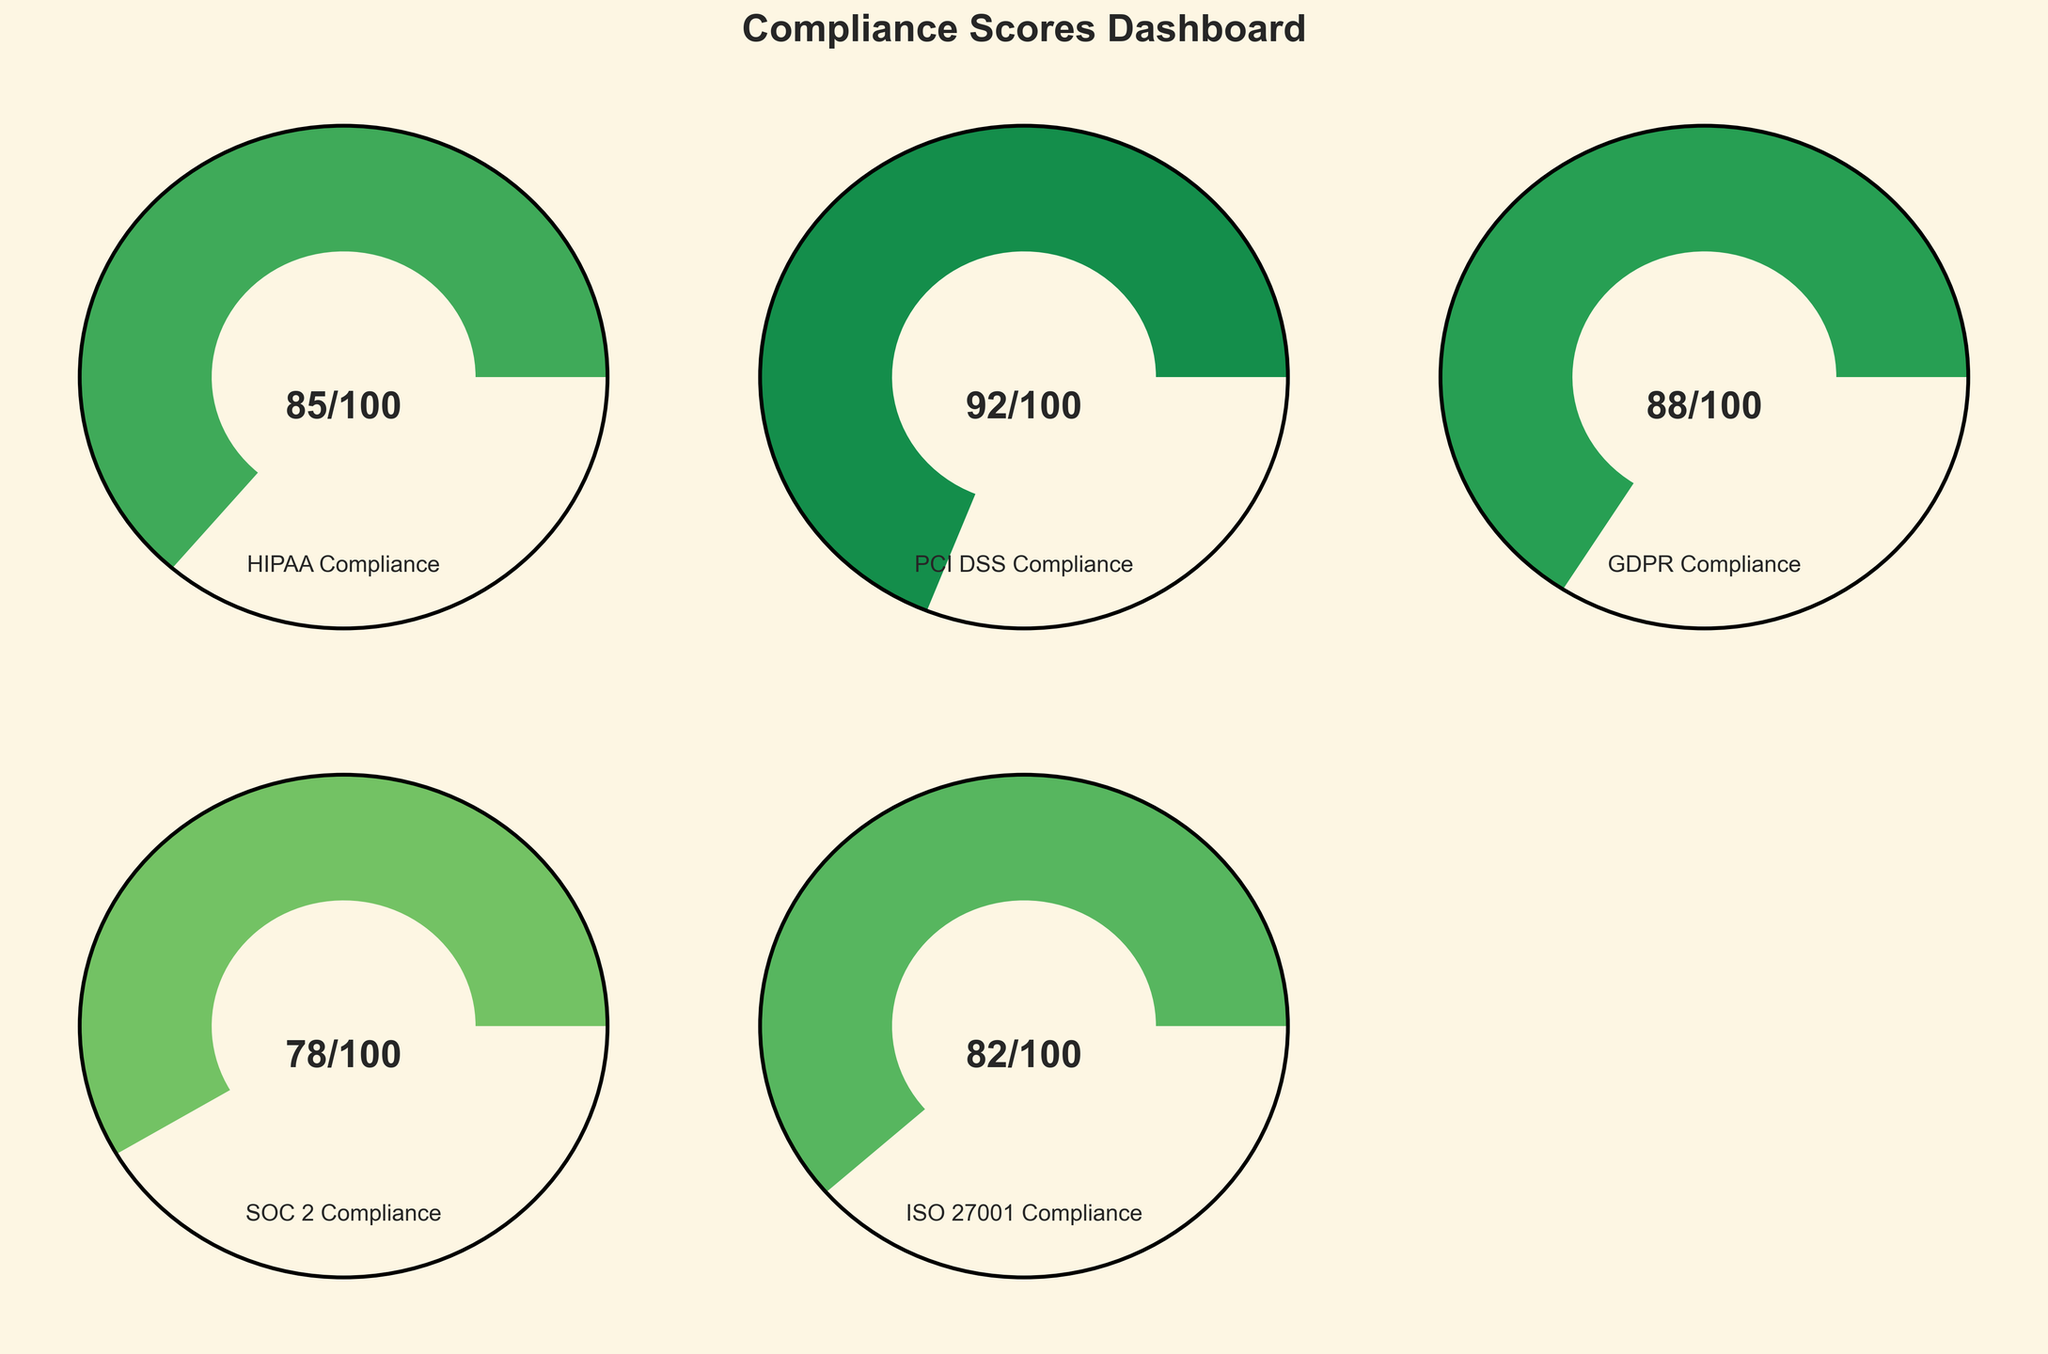What's the title of the figure? The title is prominently displayed at the top of the figure and reads 'Compliance Scores Dashboard'.
Answer: Compliance Scores Dashboard How many categories of compliance scores are shown in the figure? The figure displays one gauge chart for each category of compliance score. We count the number of distinct categories labeled in each gauge chart.
Answer: 5 Which compliance category has the highest score? By looking at the scores shown in each gauge chart, PCI DSS Compliance has the highest score of 92 out of 100.
Answer: PCI DSS Compliance What is the score for SOC 2 Compliance? The score for SOC 2 Compliance is specifically labeled on its corresponding gauge chart and reads 78 out of 100.
Answer: 78 What is the average compliance score across all categories? To calculate the average, sum all the scores (85 + 92 + 88 + 78 + 82) which is 425, then divide by the number of categories which is 5. The average score is 425/5 = 85.
Answer: 85 Which compliance category has the lowest score? By comparing the scores displayed on each gauge chart, SOC 2 Compliance has the lowest score of 78 out of 100.
Answer: SOC 2 Compliance Compare the scores of HIPAA Compliance and GDPR Compliance. Which one is higher and by how much? HIPAA Compliance has a score of 85, while GDPR Compliance has a score of 88. By subtracting the scores, 88 - 85, we see that GDPR Compliance is 3 points higher than HIPAA Compliance.
Answer: GDPR Compliance by 3 points What are the gauge colors representing the scores based on? The gauge colors are determined by the compliance score, with higher scores represented by greener colors and lower scores by redder colors, based on a colormap spectrum.
Answer: Compliance score What category is depicted in the gauge chart located in the top right corner of the figure? The gauge chart in the top right corner of the layout represents the PCI DSS Compliance category.
Answer: PCI DSS Compliance 